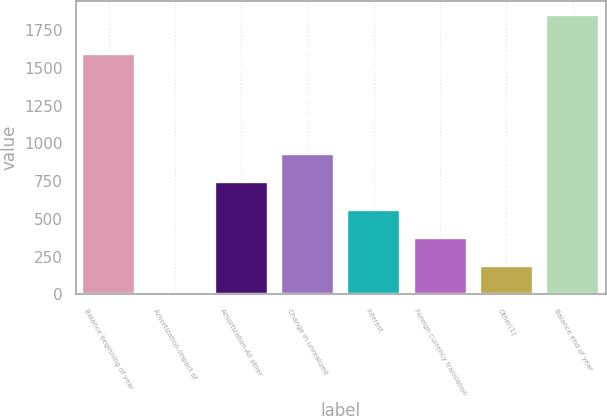<chart> <loc_0><loc_0><loc_500><loc_500><bar_chart><fcel>Balance beginning of year<fcel>Amortization-Impact of<fcel>Amortization-All other<fcel>Change in unrealized<fcel>Interest<fcel>Foreign currency translation<fcel>Other(1)<fcel>Balance end of year<nl><fcel>1591<fcel>4.2<fcel>742.52<fcel>927.1<fcel>557.94<fcel>373.36<fcel>188.78<fcel>1850<nl></chart> 